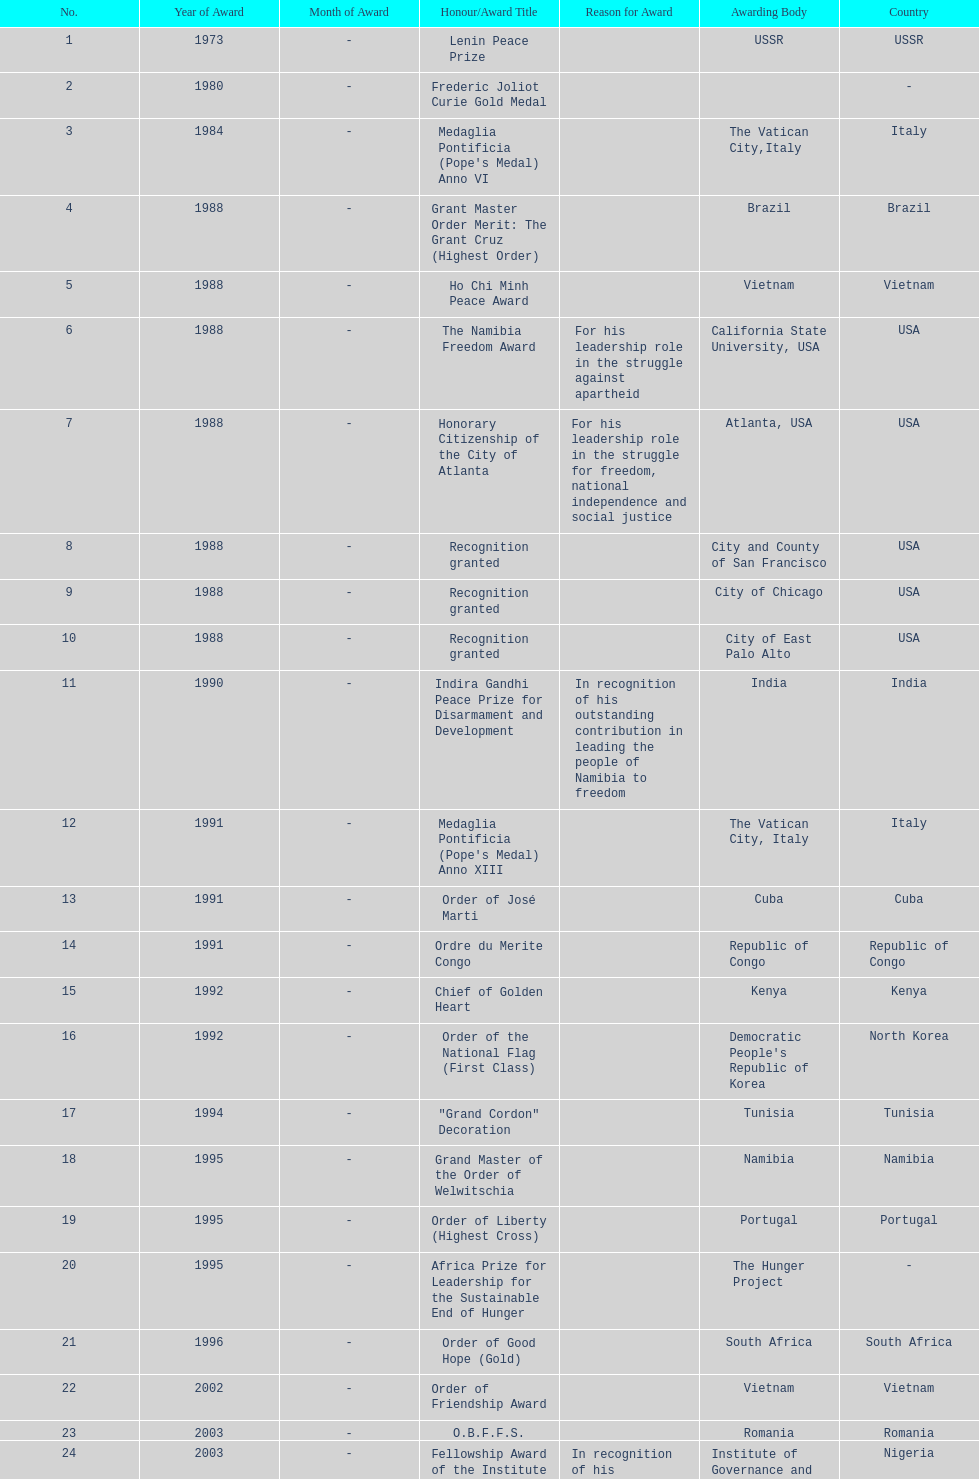What is the difference between the number of awards won in 1988 and the number of awards won in 1995? 4. 